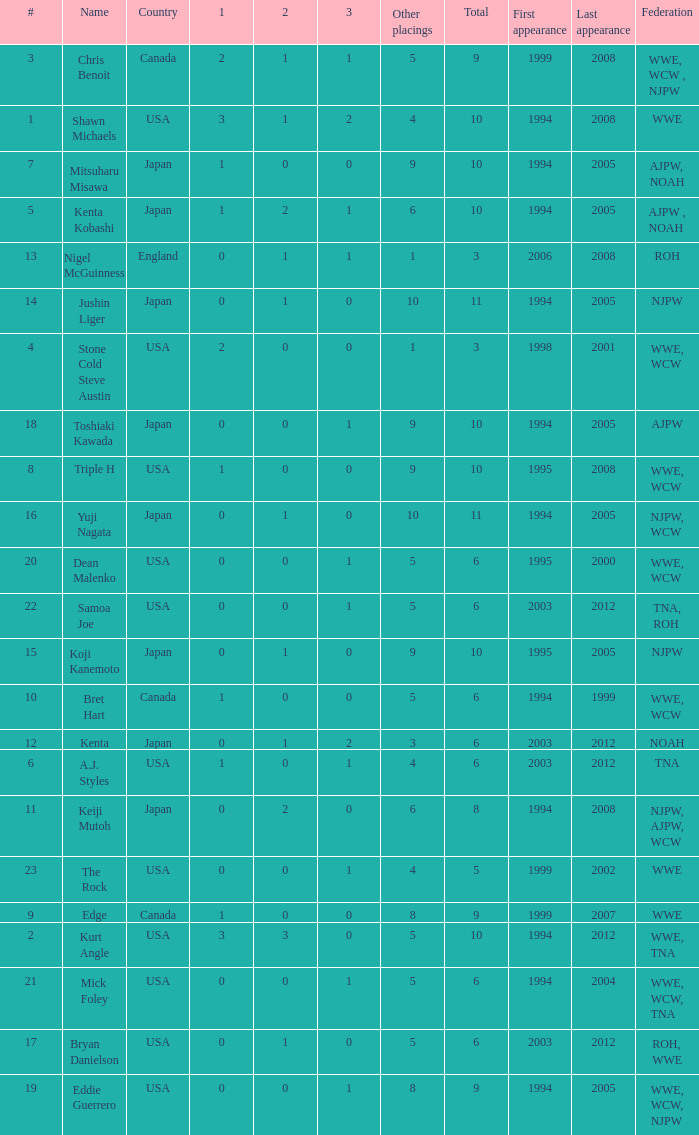What countries does the Rock come from? 1.0. 